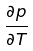Convert formula to latex. <formula><loc_0><loc_0><loc_500><loc_500>\frac { \partial p } { \partial T }</formula> 